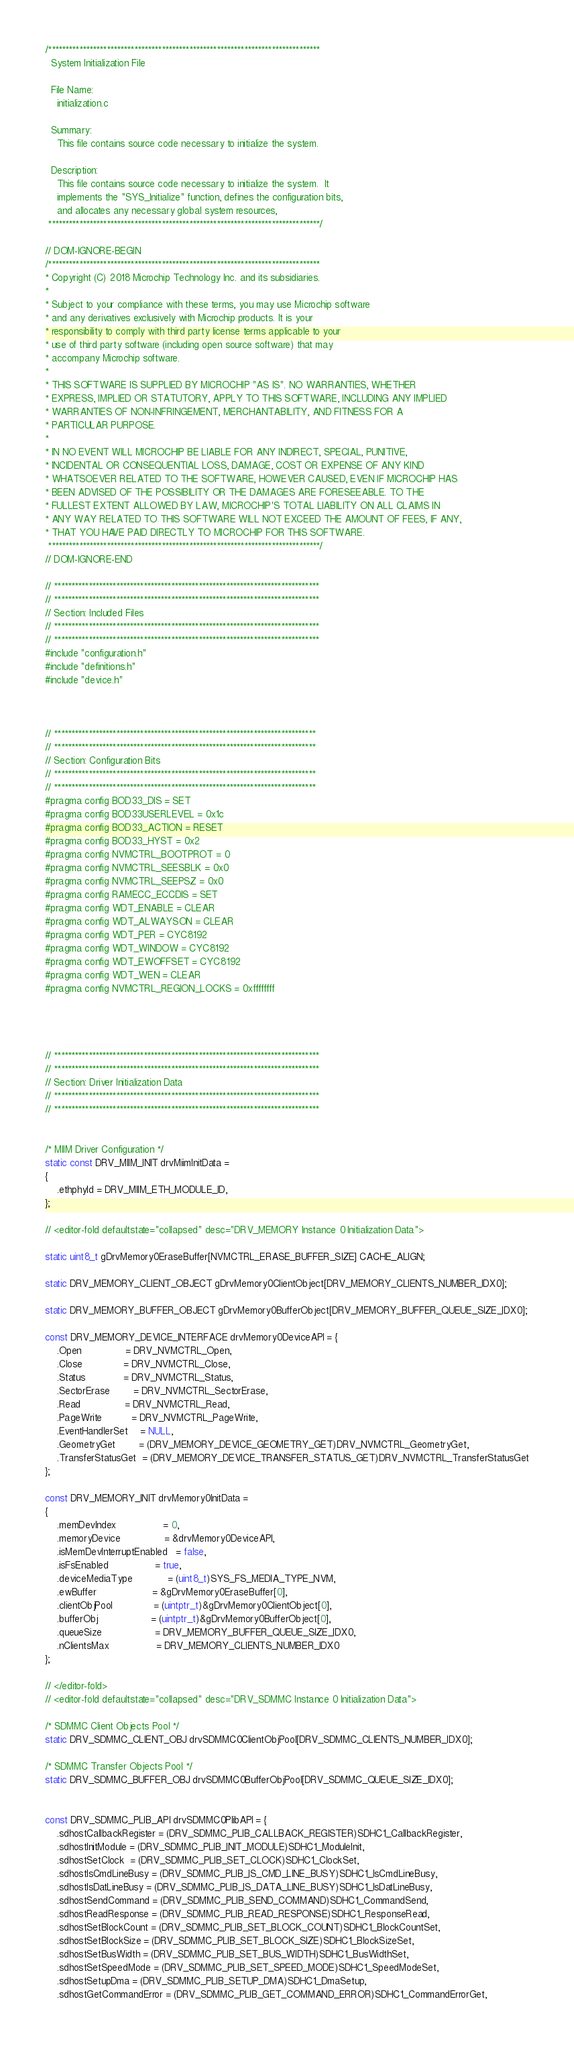<code> <loc_0><loc_0><loc_500><loc_500><_C_>/*******************************************************************************
  System Initialization File

  File Name:
    initialization.c

  Summary:
    This file contains source code necessary to initialize the system.

  Description:
    This file contains source code necessary to initialize the system.  It
    implements the "SYS_Initialize" function, defines the configuration bits,
    and allocates any necessary global system resources,
 *******************************************************************************/

// DOM-IGNORE-BEGIN
/*******************************************************************************
* Copyright (C) 2018 Microchip Technology Inc. and its subsidiaries.
*
* Subject to your compliance with these terms, you may use Microchip software
* and any derivatives exclusively with Microchip products. It is your
* responsibility to comply with third party license terms applicable to your
* use of third party software (including open source software) that may
* accompany Microchip software.
*
* THIS SOFTWARE IS SUPPLIED BY MICROCHIP "AS IS". NO WARRANTIES, WHETHER
* EXPRESS, IMPLIED OR STATUTORY, APPLY TO THIS SOFTWARE, INCLUDING ANY IMPLIED
* WARRANTIES OF NON-INFRINGEMENT, MERCHANTABILITY, AND FITNESS FOR A
* PARTICULAR PURPOSE.
*
* IN NO EVENT WILL MICROCHIP BE LIABLE FOR ANY INDIRECT, SPECIAL, PUNITIVE,
* INCIDENTAL OR CONSEQUENTIAL LOSS, DAMAGE, COST OR EXPENSE OF ANY KIND
* WHATSOEVER RELATED TO THE SOFTWARE, HOWEVER CAUSED, EVEN IF MICROCHIP HAS
* BEEN ADVISED OF THE POSSIBILITY OR THE DAMAGES ARE FORESEEABLE. TO THE
* FULLEST EXTENT ALLOWED BY LAW, MICROCHIP'S TOTAL LIABILITY ON ALL CLAIMS IN
* ANY WAY RELATED TO THIS SOFTWARE WILL NOT EXCEED THE AMOUNT OF FEES, IF ANY,
* THAT YOU HAVE PAID DIRECTLY TO MICROCHIP FOR THIS SOFTWARE.
 *******************************************************************************/
// DOM-IGNORE-END

// *****************************************************************************
// *****************************************************************************
// Section: Included Files
// *****************************************************************************
// *****************************************************************************
#include "configuration.h"
#include "definitions.h"
#include "device.h"



// ****************************************************************************
// ****************************************************************************
// Section: Configuration Bits
// ****************************************************************************
// ****************************************************************************
#pragma config BOD33_DIS = SET
#pragma config BOD33USERLEVEL = 0x1c
#pragma config BOD33_ACTION = RESET
#pragma config BOD33_HYST = 0x2
#pragma config NVMCTRL_BOOTPROT = 0
#pragma config NVMCTRL_SEESBLK = 0x0
#pragma config NVMCTRL_SEEPSZ = 0x0
#pragma config RAMECC_ECCDIS = SET
#pragma config WDT_ENABLE = CLEAR
#pragma config WDT_ALWAYSON = CLEAR
#pragma config WDT_PER = CYC8192
#pragma config WDT_WINDOW = CYC8192
#pragma config WDT_EWOFFSET = CYC8192
#pragma config WDT_WEN = CLEAR
#pragma config NVMCTRL_REGION_LOCKS = 0xffffffff




// *****************************************************************************
// *****************************************************************************
// Section: Driver Initialization Data
// *****************************************************************************
// *****************************************************************************


/* MIIM Driver Configuration */
static const DRV_MIIM_INIT drvMiimInitData =
{
    .ethphyId = DRV_MIIM_ETH_MODULE_ID,
};

// <editor-fold defaultstate="collapsed" desc="DRV_MEMORY Instance 0 Initialization Data">

static uint8_t gDrvMemory0EraseBuffer[NVMCTRL_ERASE_BUFFER_SIZE] CACHE_ALIGN;

static DRV_MEMORY_CLIENT_OBJECT gDrvMemory0ClientObject[DRV_MEMORY_CLIENTS_NUMBER_IDX0];

static DRV_MEMORY_BUFFER_OBJECT gDrvMemory0BufferObject[DRV_MEMORY_BUFFER_QUEUE_SIZE_IDX0];

const DRV_MEMORY_DEVICE_INTERFACE drvMemory0DeviceAPI = {
    .Open               = DRV_NVMCTRL_Open,
    .Close              = DRV_NVMCTRL_Close,
    .Status             = DRV_NVMCTRL_Status,
    .SectorErase        = DRV_NVMCTRL_SectorErase,
    .Read               = DRV_NVMCTRL_Read,
    .PageWrite          = DRV_NVMCTRL_PageWrite,
    .EventHandlerSet    = NULL,
    .GeometryGet        = (DRV_MEMORY_DEVICE_GEOMETRY_GET)DRV_NVMCTRL_GeometryGet,
    .TransferStatusGet  = (DRV_MEMORY_DEVICE_TRANSFER_STATUS_GET)DRV_NVMCTRL_TransferStatusGet
};

const DRV_MEMORY_INIT drvMemory0InitData =
{
    .memDevIndex                = 0,
    .memoryDevice               = &drvMemory0DeviceAPI,
    .isMemDevInterruptEnabled   = false,
    .isFsEnabled                = true,
    .deviceMediaType            = (uint8_t)SYS_FS_MEDIA_TYPE_NVM,
    .ewBuffer                   = &gDrvMemory0EraseBuffer[0],
    .clientObjPool              = (uintptr_t)&gDrvMemory0ClientObject[0],
    .bufferObj                  = (uintptr_t)&gDrvMemory0BufferObject[0],
    .queueSize                  = DRV_MEMORY_BUFFER_QUEUE_SIZE_IDX0,
    .nClientsMax                = DRV_MEMORY_CLIENTS_NUMBER_IDX0
};

// </editor-fold>
// <editor-fold defaultstate="collapsed" desc="DRV_SDMMC Instance 0 Initialization Data">

/* SDMMC Client Objects Pool */
static DRV_SDMMC_CLIENT_OBJ drvSDMMC0ClientObjPool[DRV_SDMMC_CLIENTS_NUMBER_IDX0];

/* SDMMC Transfer Objects Pool */
static DRV_SDMMC_BUFFER_OBJ drvSDMMC0BufferObjPool[DRV_SDMMC_QUEUE_SIZE_IDX0];


const DRV_SDMMC_PLIB_API drvSDMMC0PlibAPI = {
    .sdhostCallbackRegister = (DRV_SDMMC_PLIB_CALLBACK_REGISTER)SDHC1_CallbackRegister,
    .sdhostInitModule = (DRV_SDMMC_PLIB_INIT_MODULE)SDHC1_ModuleInit,
    .sdhostSetClock  = (DRV_SDMMC_PLIB_SET_CLOCK)SDHC1_ClockSet,
    .sdhostIsCmdLineBusy = (DRV_SDMMC_PLIB_IS_CMD_LINE_BUSY)SDHC1_IsCmdLineBusy,
    .sdhostIsDatLineBusy = (DRV_SDMMC_PLIB_IS_DATA_LINE_BUSY)SDHC1_IsDatLineBusy,
    .sdhostSendCommand = (DRV_SDMMC_PLIB_SEND_COMMAND)SDHC1_CommandSend,
    .sdhostReadResponse = (DRV_SDMMC_PLIB_READ_RESPONSE)SDHC1_ResponseRead,
    .sdhostSetBlockCount = (DRV_SDMMC_PLIB_SET_BLOCK_COUNT)SDHC1_BlockCountSet,
    .sdhostSetBlockSize = (DRV_SDMMC_PLIB_SET_BLOCK_SIZE)SDHC1_BlockSizeSet,
    .sdhostSetBusWidth = (DRV_SDMMC_PLIB_SET_BUS_WIDTH)SDHC1_BusWidthSet,
    .sdhostSetSpeedMode = (DRV_SDMMC_PLIB_SET_SPEED_MODE)SDHC1_SpeedModeSet,
    .sdhostSetupDma = (DRV_SDMMC_PLIB_SETUP_DMA)SDHC1_DmaSetup,
    .sdhostGetCommandError = (DRV_SDMMC_PLIB_GET_COMMAND_ERROR)SDHC1_CommandErrorGet,</code> 